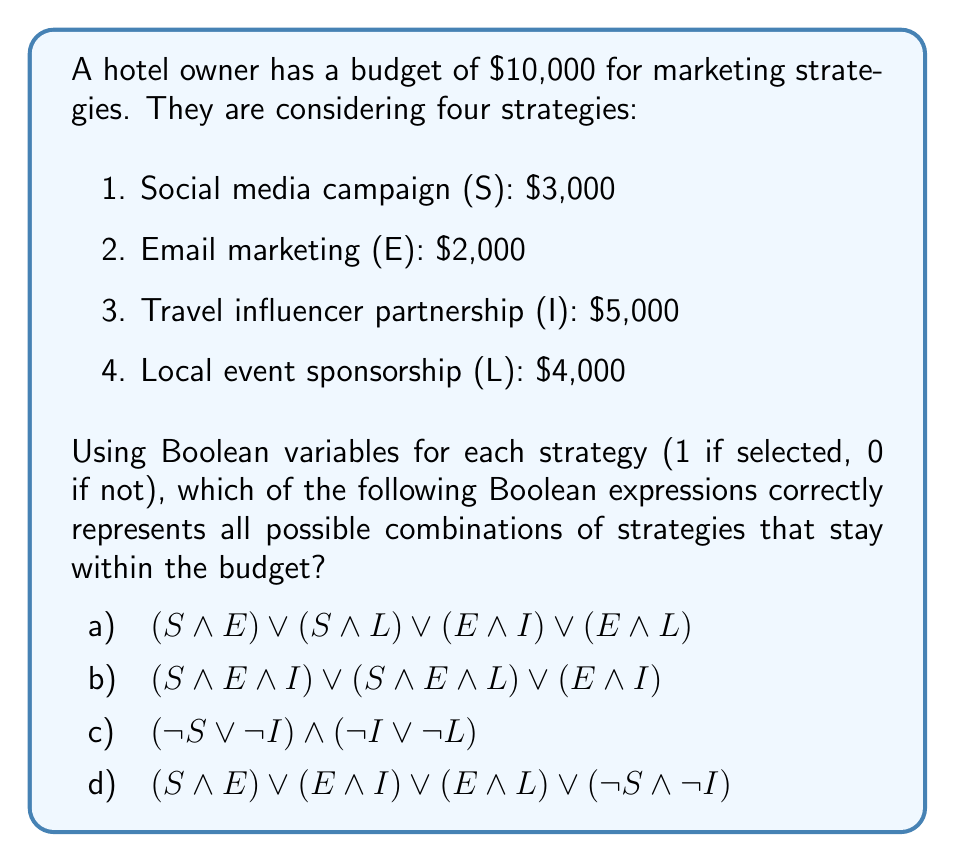Can you answer this question? Let's analyze each option step-by-step:

1) First, we need to understand what each combination costs:
   S + E = $5,000
   S + L = $7,000
   E + I = $7,000
   E + L = $6,000
   S + E + I = $10,000
   S + E + L = $9,000

2) Now, let's evaluate each option:

a) $$(S \land E) \lor (S \land L) \lor (E \land I) \lor (E \land L)$$
   This expression includes all valid combinations, but it's missing some (like E alone or S + E + L). It's not comprehensive.

b) $$(S \land E \land I) \lor (S \land E \land L) \lor (E \land I)$$
   S + E + I equals $10,000, which is at the budget limit. S + E + L and E + I are within budget. However, this misses many valid combinations.

c) $$(\neg S \lor \neg I) \land (\neg I \lor \neg L)$$
   This expression ensures that S and I aren't both selected, and I and L aren't both selected. However, it doesn't account for the budget constraint comprehensively.

d) $$(S \land E) \lor (E \land I) \lor (E \land L) \lor (\neg S \land \neg I)$$
   This expression covers all possible combinations within budget:
   - S + E is valid
   - E + I is valid
   - E + L is valid
   - ¬S ∧ ¬I allows for E, L, E+L, or no selection, all of which are within budget

   This expression excludes combinations over budget (S+I, S+L, I+L, S+E+I, S+I+L, E+I+L, S+E+I+L) while including all valid combinations.

Therefore, option d) is the correct answer.
Answer: d 